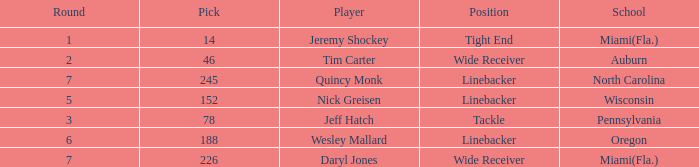From what school was the player drafted in round 3? Pennsylvania. 